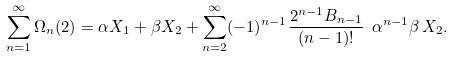<formula> <loc_0><loc_0><loc_500><loc_500>\sum _ { n = 1 } ^ { \infty } \Omega _ { n } ( 2 ) = \alpha X _ { 1 } + \beta X _ { 2 } + \sum _ { n = 2 } ^ { \infty } ( - 1 ) ^ { n - 1 } \frac { 2 ^ { n - 1 } B _ { n - 1 } } { ( n - 1 ) ! } \ \alpha ^ { n - 1 } \beta \, X _ { 2 } .</formula> 